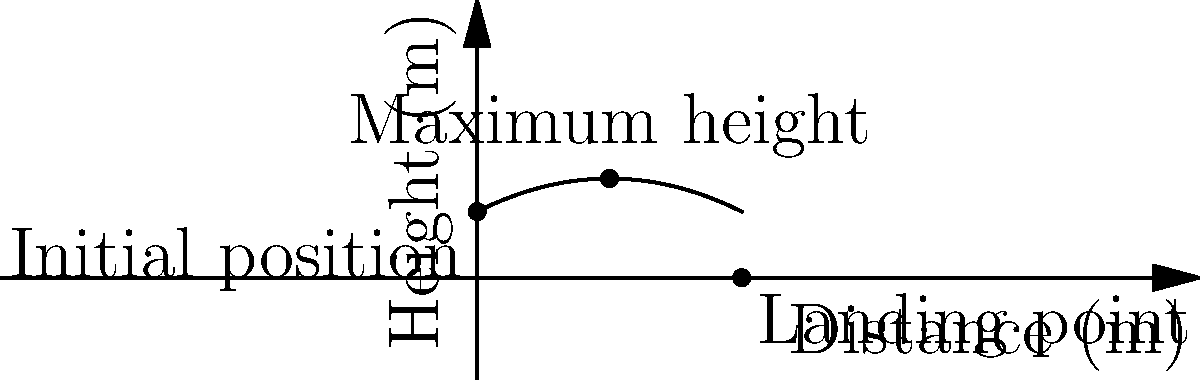During a football night at your favorite networking spot, you observe a player kicking a ball. The trajectory of the ball can be modeled by the function $h(x) = -0.025x^2 + 0.5x + 5$, where $h$ represents the height in meters and $x$ represents the horizontal distance in meters. What is the maximum height reached by the ball, and at what horizontal distance does this occur? To find the maximum height and its corresponding horizontal distance, we need to follow these steps:

1) The maximum height occurs at the vertex of the parabola. For a quadratic function in the form $f(x) = ax^2 + bx + c$, the x-coordinate of the vertex is given by $x = -\frac{b}{2a}$.

2) In our function $h(x) = -0.025x^2 + 0.5x + 5$:
   $a = -0.025$
   $b = 0.5$
   $c = 5$

3) Calculate the x-coordinate of the vertex:
   $x = -\frac{b}{2a} = -\frac{0.5}{2(-0.025)} = 10$ meters

4) To find the maximum height, substitute this x-value into the original function:
   $h(10) = -0.025(10)^2 + 0.5(10) + 5$
   $= -0.025(100) + 5 + 5$
   $= -2.5 + 5 + 5$
   $= 7.5$ meters

Therefore, the ball reaches its maximum height of 7.5 meters at a horizontal distance of 10 meters from the kicking point.
Answer: Maximum height: 7.5 meters; Horizontal distance: 10 meters 